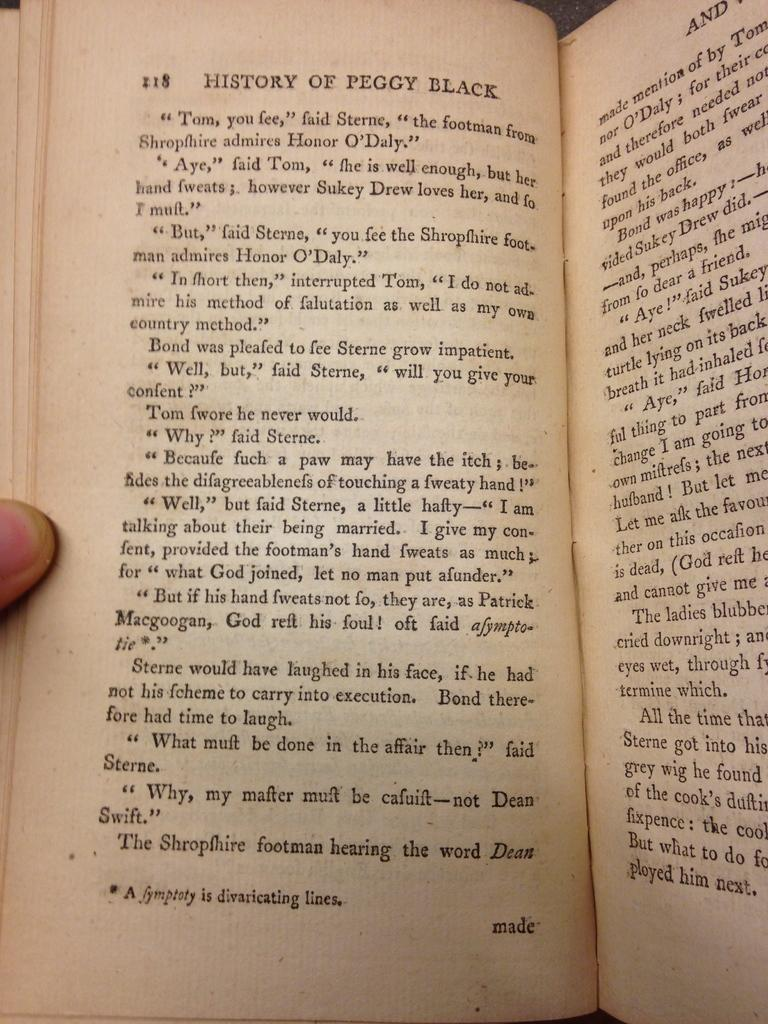<image>
Describe the image concisely. a page of the book titled "history of peggy black. 